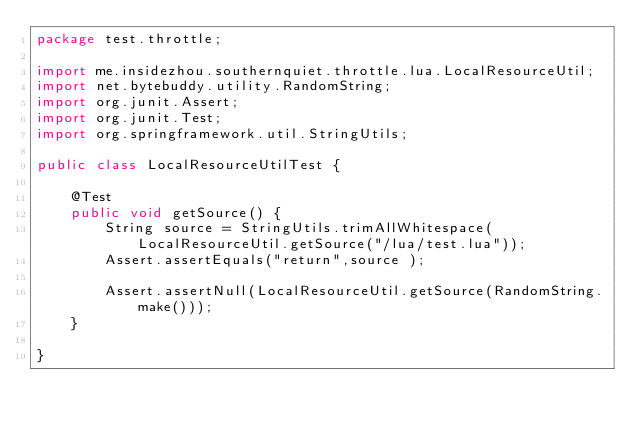<code> <loc_0><loc_0><loc_500><loc_500><_Java_>package test.throttle;

import me.insidezhou.southernquiet.throttle.lua.LocalResourceUtil;
import net.bytebuddy.utility.RandomString;
import org.junit.Assert;
import org.junit.Test;
import org.springframework.util.StringUtils;

public class LocalResourceUtilTest {

    @Test
    public void getSource() {
        String source = StringUtils.trimAllWhitespace(LocalResourceUtil.getSource("/lua/test.lua"));
        Assert.assertEquals("return",source );

        Assert.assertNull(LocalResourceUtil.getSource(RandomString.make()));
    }

}
</code> 